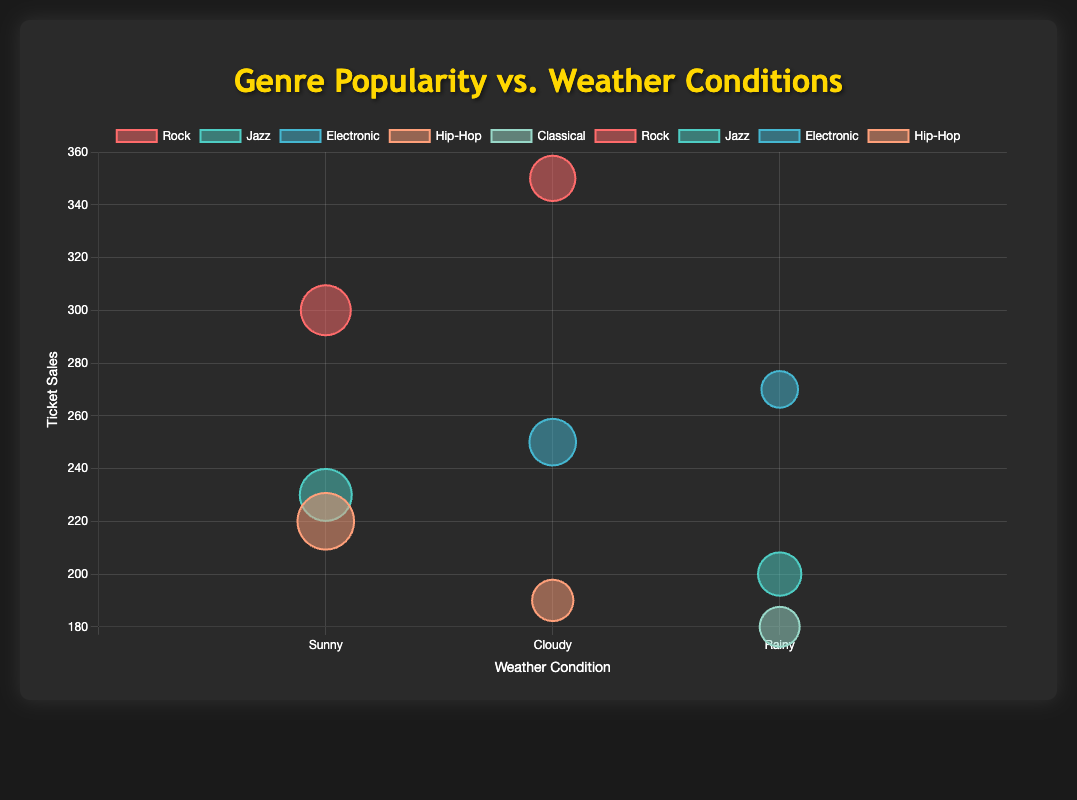What genre has the highest ticket sales during sunny weather? Look for the data points in sunny weather and compare their ticket sales. The highest ticket sales in sunny weather are for the Rock genre with 300 tickets.
Answer: Rock What is the weather condition with the lowest ticket sales for Hip-Hop? Identify the Hip-Hop data points and compare their ticket sales. The lowest ticket sales for Hip-Hop are during cloudy weather with 190 tickets.
Answer: Cloudy Which genre has the highest ticket sales overall regardless of weather? Compare the ticket sales across all genres. The highest ticket sales are 350, which is for Rock.
Answer: Rock How does the form of the bubble (diameter) change with temperature? The diameter indicates temperature, so higher temperatures result in larger bubbles. For example, the Hip-Hop bubble at 85°F is larger than the Classical bubble at 60°F.
Answer: Bubbles increase in size If you sum the ticket sales for Jazz and Classical genres, what's the total? Sum the ticket sales for all Jazz and Classical data points. Jazz: 200 + 230 = 430, Classical: 180, Total: 430 + 180 = 610.
Answer: 610 Which weather condition has the highest ticket sales for the Jazz genre? Compare the ticket sales for Jazz in different weather conditions. The highest ticket sales for Jazz occur in sunny weather with 230 tickets.
Answer: Sunny Given that the y-axis represents ticket sales, how many genres had ticket sales of 250 or more in rainy weather? Look for data points in rainy weather and examine their ticket sales. Electronic with 270 tickets meets this condition. Only one such data point exists.
Answer: 1 What is the range of temperatures observed for the Electronic genre? Identify the temperature values for all Electronic data points and calculate the range. The temperatures are 70 and 55. The range is 70 - 55 = 15°F.
Answer: 15°F What is the average temperature for the events that occurred in sunny weather? Sum the temperatures for sunny weather events and divide by the number of such events. Temperatures: 75, 85, 78. Avg = (75 + 85 + 78) / 3 = 79.3°F.
Answer: 79.3°F Which genre experienced the highest ticket sales during cloudy weather? Compare the ticket sales among genres in cloudy weather. Rock had the highest ticket sales with 350 tickets.
Answer: Rock 